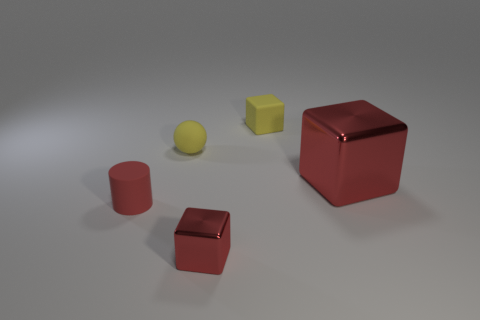Add 5 red rubber cylinders. How many objects exist? 10 Subtract all blocks. How many objects are left? 2 Add 2 large metallic blocks. How many large metallic blocks are left? 3 Add 5 tiny cylinders. How many tiny cylinders exist? 6 Subtract 0 brown cylinders. How many objects are left? 5 Subtract all small yellow rubber things. Subtract all blue rubber blocks. How many objects are left? 3 